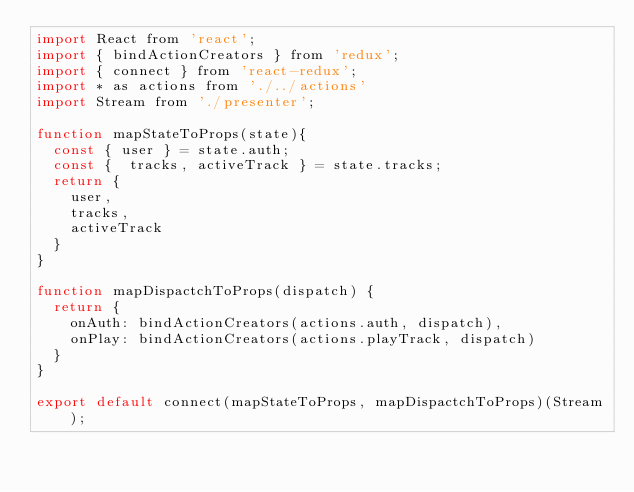<code> <loc_0><loc_0><loc_500><loc_500><_JavaScript_>import React from 'react';
import { bindActionCreators } from 'redux';
import { connect } from 'react-redux';
import * as actions from './../actions'
import Stream from './presenter';

function mapStateToProps(state){
  const { user } = state.auth;
  const {  tracks, activeTrack } = state.tracks;
  return {
    user,
    tracks,
    activeTrack
  }
}

function mapDispactchToProps(dispatch) {
  return {
    onAuth: bindActionCreators(actions.auth, dispatch),
    onPlay: bindActionCreators(actions.playTrack, dispatch)
  }
}

export default connect(mapStateToProps, mapDispactchToProps)(Stream);
</code> 